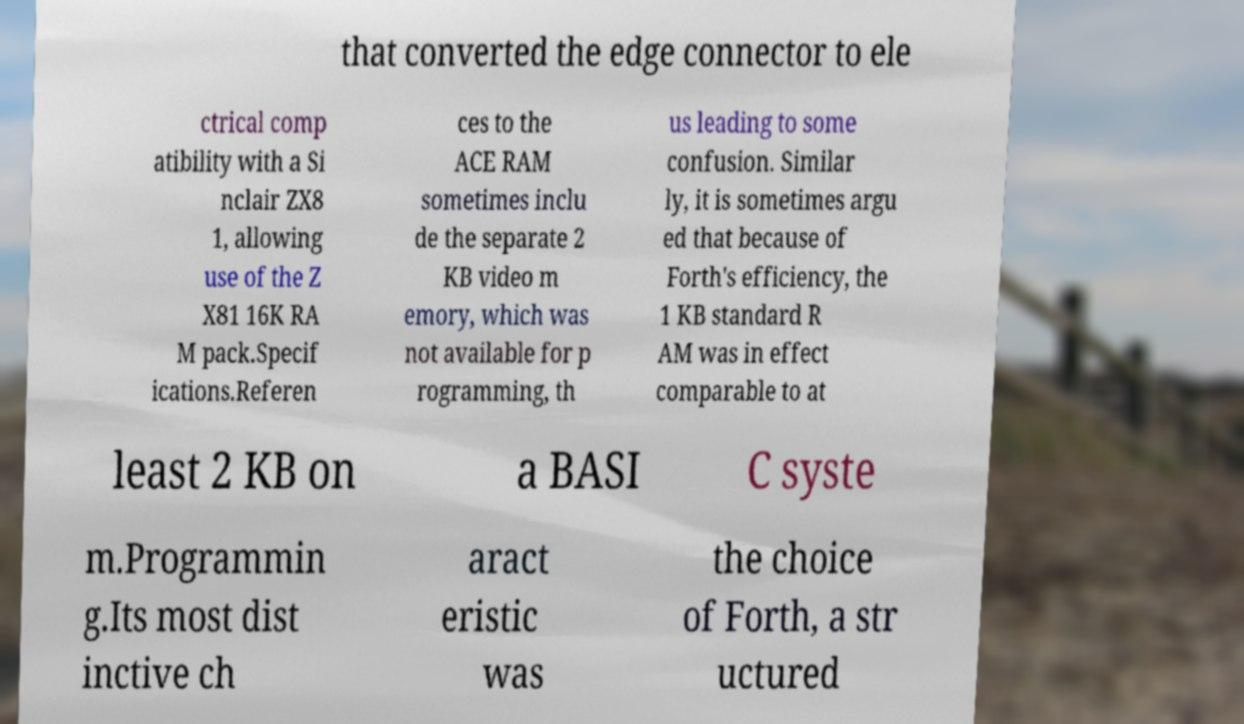Can you accurately transcribe the text from the provided image for me? that converted the edge connector to ele ctrical comp atibility with a Si nclair ZX8 1, allowing use of the Z X81 16K RA M pack.Specif ications.Referen ces to the ACE RAM sometimes inclu de the separate 2 KB video m emory, which was not available for p rogramming, th us leading to some confusion. Similar ly, it is sometimes argu ed that because of Forth's efficiency, the 1 KB standard R AM was in effect comparable to at least 2 KB on a BASI C syste m.Programmin g.Its most dist inctive ch aract eristic was the choice of Forth, a str uctured 